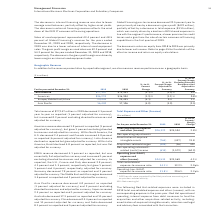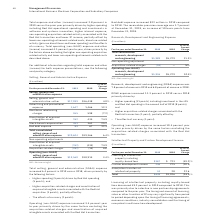According to International Business Machines's financial document, What activity impacted the 2019 results? 2019 results were impacted by Red Hat purchase accounting and acquisition-related activity.. The document states: "* 2019 results were impacted by Red Hat purchase accounting and acquisition-related activity...." Also, What expenses were included in 2019 total consolidated expenses and other (income)? Red Hat operational spending, interest expense from debt issuances to fund the acquisition and other acquisition-related activity, including: amortization of acquired intangible assets, retention and legal and advisory fees associated with the transaction.. The document states: ", with no corresponding expense in the prior-year: Red Hat operational spending, interest expense from debt issuances to fund the acquisition and othe..." Also, What caused the increase in the total operating expenses? Total operating (non-GAAP) expense and other (income) increased 4.1 percent year to year, driven primarily by the factors above excluding the higher non-operating acquisition related activity and lower non-operating retirement-related costs described above.. The document states: "s and lower spending) and the effects of currency. Total operating (non-GAAP) expense and other (income) increased 4.1 percent year to year, driven pr..." Also, can you calculate: What is the average of Total consolidated expense and other (income)? To answer this question, I need to perform calculations using the financial data. The calculation is: (26,322 + 25,594) / 2, which equals 25958 (in millions). This is based on the information: "consolidated expense and other (income) $26,322 $25,594 2.8% Total consolidated expense and other (income) $26,322 $25,594 2.8%..." The key data points involved are: 25,594, 26,322. Also, can you calculate: What is the increase / (decrease) in the Amortization of acquired intangible assets from 2018 to 2019? Based on the calculation: -764 - ( -437), the result is -327 (in millions). This is based on the information: "Amortization of acquired intangible assets (764) (437) 74.8 Amortization of acquired intangible assets (764) (437) 74.8..." The key data points involved are: 437, 764. Also, can you calculate: What is the increase / (decrease) in the Operating (non-GAAP) expense and other (income) from 2018 to 2019? Based on the calculation: 24,533 - 23,569, the result is 964 (in millions). This is based on the information: "Operating (non-GAAP) expense and other (income) $24,533 $23,569 4.1% ng (non-GAAP) expense and other (income) $24,533 $23,569 4.1%..." The key data points involved are: 23,569, 24,533. 